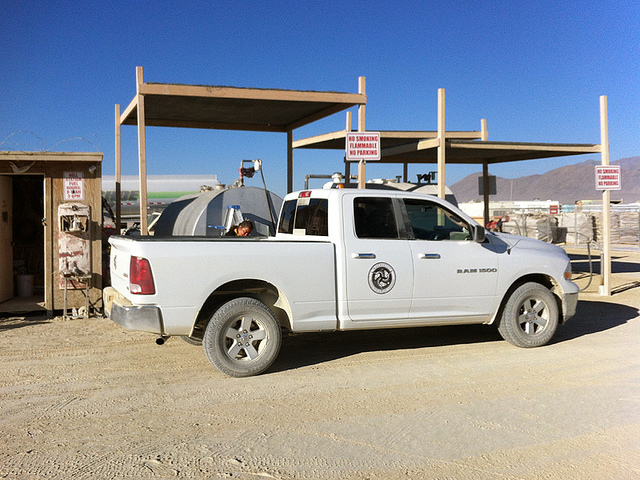Read and extract the text from this image. BAR 